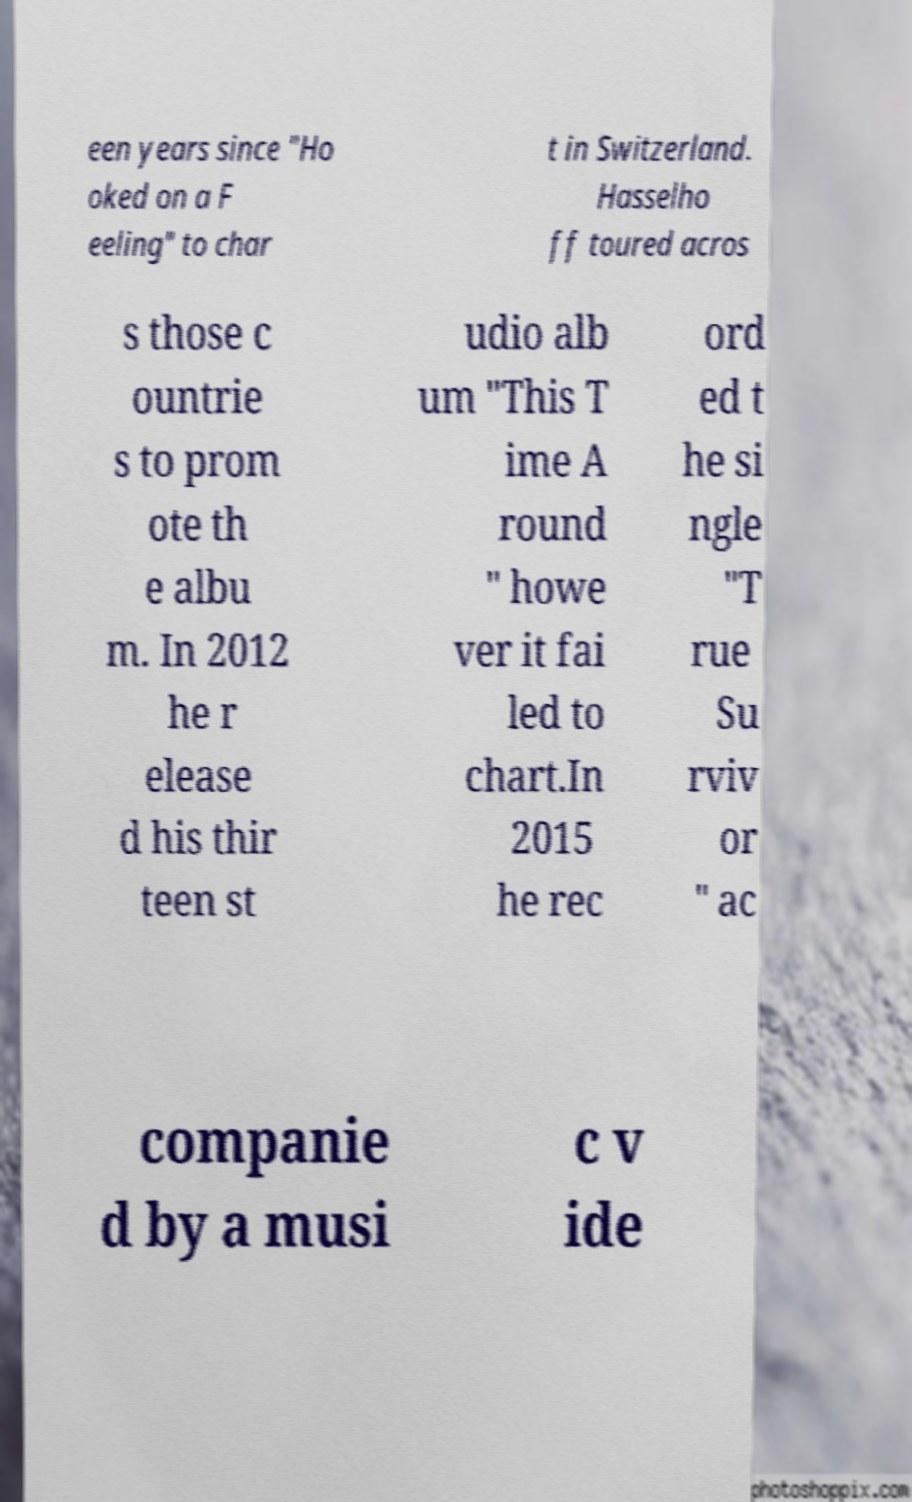Could you assist in decoding the text presented in this image and type it out clearly? een years since "Ho oked on a F eeling" to char t in Switzerland. Hasselho ff toured acros s those c ountrie s to prom ote th e albu m. In 2012 he r elease d his thir teen st udio alb um "This T ime A round " howe ver it fai led to chart.In 2015 he rec ord ed t he si ngle "T rue Su rviv or " ac companie d by a musi c v ide 